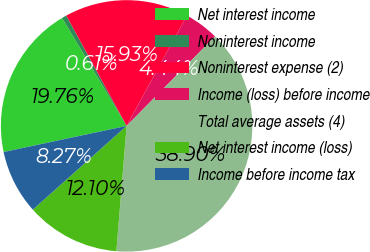Convert chart to OTSL. <chart><loc_0><loc_0><loc_500><loc_500><pie_chart><fcel>Net interest income<fcel>Noninterest income<fcel>Noninterest expense (2)<fcel>Income (loss) before income<fcel>Total average assets (4)<fcel>Net interest income (loss)<fcel>Income before income tax<nl><fcel>19.76%<fcel>0.61%<fcel>15.93%<fcel>4.44%<fcel>38.9%<fcel>12.1%<fcel>8.27%<nl></chart> 